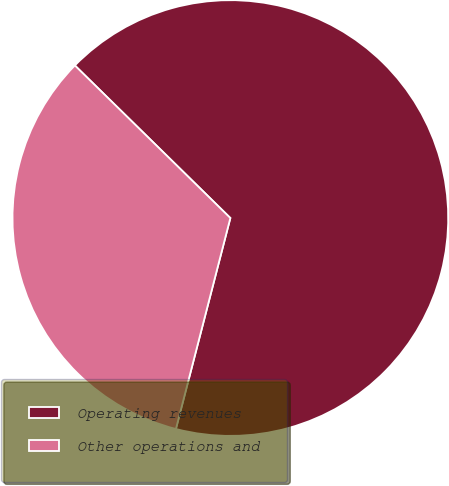Convert chart to OTSL. <chart><loc_0><loc_0><loc_500><loc_500><pie_chart><fcel>Operating revenues<fcel>Other operations and<nl><fcel>66.67%<fcel>33.33%<nl></chart> 